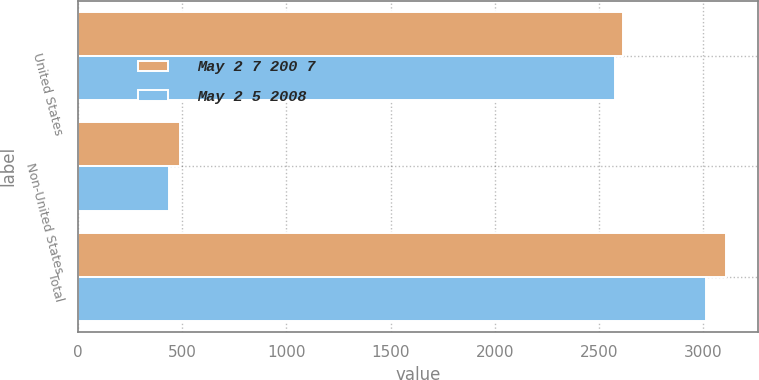<chart> <loc_0><loc_0><loc_500><loc_500><stacked_bar_chart><ecel><fcel>United States<fcel>Non-United States<fcel>Total<nl><fcel>May 2 7 200 7<fcel>2617.1<fcel>491<fcel>3108.1<nl><fcel>May 2 5 2008<fcel>2576.5<fcel>437.4<fcel>3013.9<nl></chart> 